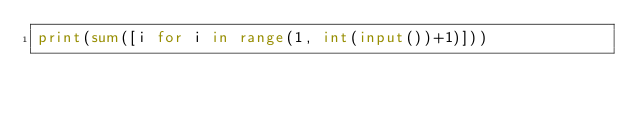Convert code to text. <code><loc_0><loc_0><loc_500><loc_500><_Python_>print(sum([i for i in range(1, int(input())+1)]))</code> 